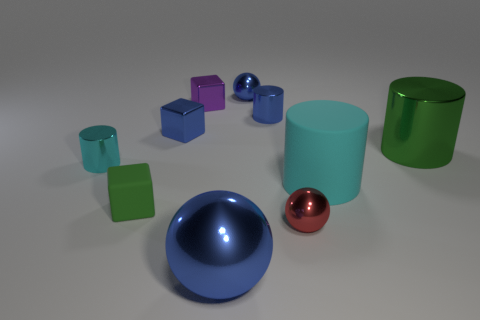Can you describe the texture and color of the large sphere in the center? The large sphere at the center has a highly reflective surface with a deep blue color. It exhibits a smooth texture that mirrors its surroundings, creating specular highlights and adding depth to the scene. 